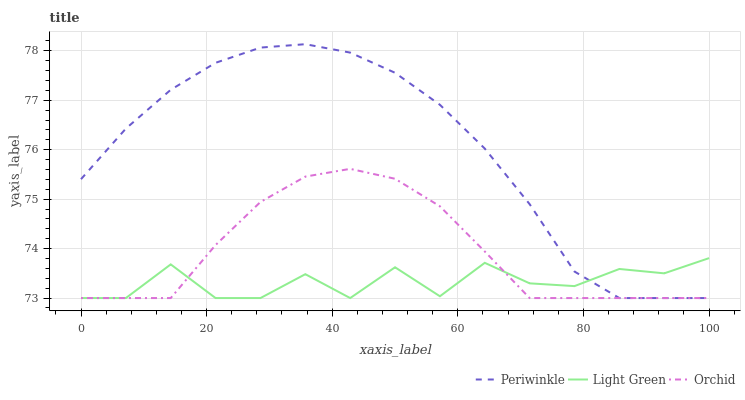Does Light Green have the minimum area under the curve?
Answer yes or no. Yes. Does Periwinkle have the maximum area under the curve?
Answer yes or no. Yes. Does Orchid have the minimum area under the curve?
Answer yes or no. No. Does Orchid have the maximum area under the curve?
Answer yes or no. No. Is Periwinkle the smoothest?
Answer yes or no. Yes. Is Light Green the roughest?
Answer yes or no. Yes. Is Orchid the smoothest?
Answer yes or no. No. Is Orchid the roughest?
Answer yes or no. No. Does Periwinkle have the lowest value?
Answer yes or no. Yes. Does Periwinkle have the highest value?
Answer yes or no. Yes. Does Orchid have the highest value?
Answer yes or no. No. Does Orchid intersect Periwinkle?
Answer yes or no. Yes. Is Orchid less than Periwinkle?
Answer yes or no. No. Is Orchid greater than Periwinkle?
Answer yes or no. No. 